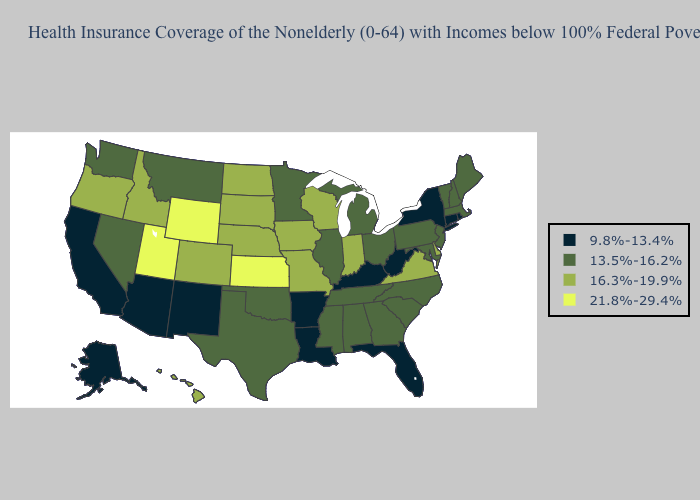What is the value of Arkansas?
Write a very short answer. 9.8%-13.4%. What is the highest value in states that border Virginia?
Answer briefly. 13.5%-16.2%. Name the states that have a value in the range 21.8%-29.4%?
Be succinct. Kansas, Utah, Wyoming. What is the lowest value in the MidWest?
Answer briefly. 13.5%-16.2%. Among the states that border Georgia , does Tennessee have the lowest value?
Concise answer only. No. What is the highest value in the USA?
Short answer required. 21.8%-29.4%. Which states have the lowest value in the Northeast?
Write a very short answer. Connecticut, New York, Rhode Island. Name the states that have a value in the range 13.5%-16.2%?
Quick response, please. Alabama, Georgia, Illinois, Maine, Maryland, Massachusetts, Michigan, Minnesota, Mississippi, Montana, Nevada, New Hampshire, New Jersey, North Carolina, Ohio, Oklahoma, Pennsylvania, South Carolina, Tennessee, Texas, Vermont, Washington. Is the legend a continuous bar?
Be succinct. No. What is the value of Maryland?
Keep it brief. 13.5%-16.2%. Does Kansas have the highest value in the MidWest?
Concise answer only. Yes. Name the states that have a value in the range 9.8%-13.4%?
Be succinct. Alaska, Arizona, Arkansas, California, Connecticut, Florida, Kentucky, Louisiana, New Mexico, New York, Rhode Island, West Virginia. What is the lowest value in the Northeast?
Be succinct. 9.8%-13.4%. What is the lowest value in the USA?
Write a very short answer. 9.8%-13.4%. What is the lowest value in states that border Missouri?
Keep it brief. 9.8%-13.4%. 